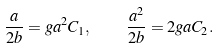Convert formula to latex. <formula><loc_0><loc_0><loc_500><loc_500>\frac { a } { 2 b } = g a ^ { 2 } C _ { 1 } , \quad \frac { a ^ { 2 } } { 2 b } = 2 g a C _ { 2 } .</formula> 